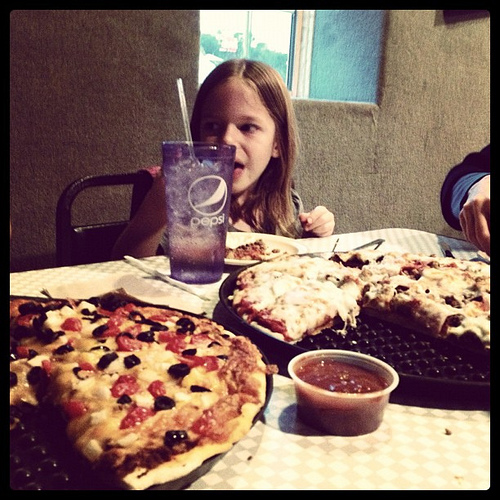What toppings can be seen on the pizzas? The pizzas appear to have several toppings including melted cheese, black olives, and sliced red bell peppers. There might be other toppings obscured by the cheese. 